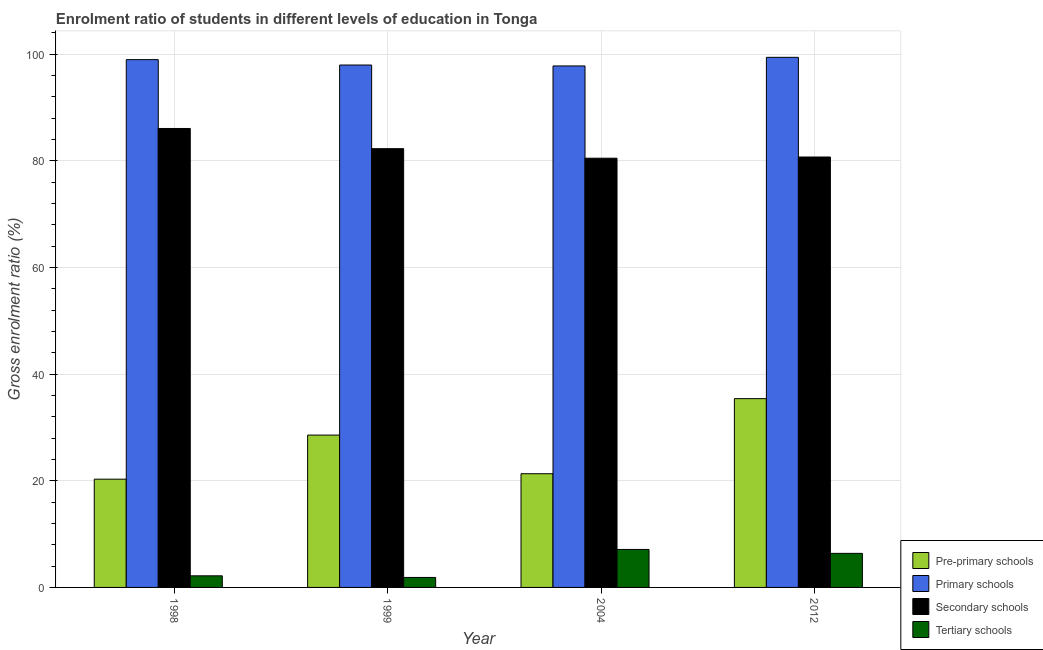How many groups of bars are there?
Keep it short and to the point. 4. Are the number of bars per tick equal to the number of legend labels?
Provide a succinct answer. Yes. How many bars are there on the 2nd tick from the right?
Make the answer very short. 4. What is the label of the 4th group of bars from the left?
Provide a short and direct response. 2012. What is the gross enrolment ratio in secondary schools in 2004?
Offer a very short reply. 80.49. Across all years, what is the maximum gross enrolment ratio in pre-primary schools?
Provide a short and direct response. 35.4. Across all years, what is the minimum gross enrolment ratio in tertiary schools?
Make the answer very short. 1.87. What is the total gross enrolment ratio in primary schools in the graph?
Offer a very short reply. 394.16. What is the difference between the gross enrolment ratio in primary schools in 1999 and that in 2012?
Offer a terse response. -1.44. What is the difference between the gross enrolment ratio in pre-primary schools in 1998 and the gross enrolment ratio in primary schools in 1999?
Offer a terse response. -8.27. What is the average gross enrolment ratio in primary schools per year?
Provide a succinct answer. 98.54. In the year 2012, what is the difference between the gross enrolment ratio in tertiary schools and gross enrolment ratio in secondary schools?
Provide a short and direct response. 0. In how many years, is the gross enrolment ratio in pre-primary schools greater than 48 %?
Provide a short and direct response. 0. What is the ratio of the gross enrolment ratio in pre-primary schools in 1999 to that in 2012?
Provide a short and direct response. 0.81. What is the difference between the highest and the second highest gross enrolment ratio in primary schools?
Offer a terse response. 0.43. What is the difference between the highest and the lowest gross enrolment ratio in primary schools?
Your answer should be very brief. 1.62. Is the sum of the gross enrolment ratio in primary schools in 1998 and 1999 greater than the maximum gross enrolment ratio in secondary schools across all years?
Offer a very short reply. Yes. Is it the case that in every year, the sum of the gross enrolment ratio in secondary schools and gross enrolment ratio in primary schools is greater than the sum of gross enrolment ratio in pre-primary schools and gross enrolment ratio in tertiary schools?
Your answer should be very brief. No. What does the 3rd bar from the left in 1998 represents?
Your answer should be compact. Secondary schools. What does the 2nd bar from the right in 2004 represents?
Offer a very short reply. Secondary schools. How many bars are there?
Offer a very short reply. 16. Does the graph contain any zero values?
Keep it short and to the point. No. Does the graph contain grids?
Provide a succinct answer. Yes. Where does the legend appear in the graph?
Provide a short and direct response. Bottom right. How are the legend labels stacked?
Offer a very short reply. Vertical. What is the title of the graph?
Provide a short and direct response. Enrolment ratio of students in different levels of education in Tonga. Does "International Development Association" appear as one of the legend labels in the graph?
Provide a succinct answer. No. What is the Gross enrolment ratio (%) of Pre-primary schools in 1998?
Provide a succinct answer. 20.3. What is the Gross enrolment ratio (%) in Primary schools in 1998?
Offer a very short reply. 98.98. What is the Gross enrolment ratio (%) of Secondary schools in 1998?
Give a very brief answer. 86.07. What is the Gross enrolment ratio (%) in Tertiary schools in 1998?
Ensure brevity in your answer.  2.18. What is the Gross enrolment ratio (%) of Pre-primary schools in 1999?
Provide a succinct answer. 28.57. What is the Gross enrolment ratio (%) in Primary schools in 1999?
Give a very brief answer. 97.97. What is the Gross enrolment ratio (%) of Secondary schools in 1999?
Your answer should be very brief. 82.28. What is the Gross enrolment ratio (%) of Tertiary schools in 1999?
Give a very brief answer. 1.87. What is the Gross enrolment ratio (%) in Pre-primary schools in 2004?
Your response must be concise. 21.32. What is the Gross enrolment ratio (%) in Primary schools in 2004?
Your answer should be compact. 97.8. What is the Gross enrolment ratio (%) in Secondary schools in 2004?
Ensure brevity in your answer.  80.49. What is the Gross enrolment ratio (%) in Tertiary schools in 2004?
Offer a very short reply. 7.12. What is the Gross enrolment ratio (%) of Pre-primary schools in 2012?
Offer a terse response. 35.4. What is the Gross enrolment ratio (%) in Primary schools in 2012?
Keep it short and to the point. 99.41. What is the Gross enrolment ratio (%) of Secondary schools in 2012?
Your response must be concise. 80.72. What is the Gross enrolment ratio (%) in Tertiary schools in 2012?
Ensure brevity in your answer.  6.39. Across all years, what is the maximum Gross enrolment ratio (%) in Pre-primary schools?
Offer a terse response. 35.4. Across all years, what is the maximum Gross enrolment ratio (%) of Primary schools?
Ensure brevity in your answer.  99.41. Across all years, what is the maximum Gross enrolment ratio (%) of Secondary schools?
Make the answer very short. 86.07. Across all years, what is the maximum Gross enrolment ratio (%) of Tertiary schools?
Ensure brevity in your answer.  7.12. Across all years, what is the minimum Gross enrolment ratio (%) in Pre-primary schools?
Keep it short and to the point. 20.3. Across all years, what is the minimum Gross enrolment ratio (%) of Primary schools?
Keep it short and to the point. 97.8. Across all years, what is the minimum Gross enrolment ratio (%) in Secondary schools?
Offer a terse response. 80.49. Across all years, what is the minimum Gross enrolment ratio (%) in Tertiary schools?
Your answer should be compact. 1.87. What is the total Gross enrolment ratio (%) in Pre-primary schools in the graph?
Offer a very short reply. 105.6. What is the total Gross enrolment ratio (%) of Primary schools in the graph?
Make the answer very short. 394.16. What is the total Gross enrolment ratio (%) in Secondary schools in the graph?
Your answer should be very brief. 329.57. What is the total Gross enrolment ratio (%) of Tertiary schools in the graph?
Provide a succinct answer. 17.56. What is the difference between the Gross enrolment ratio (%) in Pre-primary schools in 1998 and that in 1999?
Your answer should be compact. -8.27. What is the difference between the Gross enrolment ratio (%) of Primary schools in 1998 and that in 1999?
Give a very brief answer. 1.01. What is the difference between the Gross enrolment ratio (%) in Secondary schools in 1998 and that in 1999?
Keep it short and to the point. 3.79. What is the difference between the Gross enrolment ratio (%) of Tertiary schools in 1998 and that in 1999?
Give a very brief answer. 0.31. What is the difference between the Gross enrolment ratio (%) in Pre-primary schools in 1998 and that in 2004?
Offer a very short reply. -1.02. What is the difference between the Gross enrolment ratio (%) in Primary schools in 1998 and that in 2004?
Provide a succinct answer. 1.18. What is the difference between the Gross enrolment ratio (%) of Secondary schools in 1998 and that in 2004?
Your response must be concise. 5.58. What is the difference between the Gross enrolment ratio (%) of Tertiary schools in 1998 and that in 2004?
Your answer should be compact. -4.95. What is the difference between the Gross enrolment ratio (%) of Pre-primary schools in 1998 and that in 2012?
Give a very brief answer. -15.1. What is the difference between the Gross enrolment ratio (%) of Primary schools in 1998 and that in 2012?
Make the answer very short. -0.43. What is the difference between the Gross enrolment ratio (%) of Secondary schools in 1998 and that in 2012?
Keep it short and to the point. 5.35. What is the difference between the Gross enrolment ratio (%) in Tertiary schools in 1998 and that in 2012?
Provide a succinct answer. -4.21. What is the difference between the Gross enrolment ratio (%) of Pre-primary schools in 1999 and that in 2004?
Make the answer very short. 7.25. What is the difference between the Gross enrolment ratio (%) of Primary schools in 1999 and that in 2004?
Give a very brief answer. 0.17. What is the difference between the Gross enrolment ratio (%) of Secondary schools in 1999 and that in 2004?
Your answer should be compact. 1.79. What is the difference between the Gross enrolment ratio (%) of Tertiary schools in 1999 and that in 2004?
Your answer should be very brief. -5.25. What is the difference between the Gross enrolment ratio (%) of Pre-primary schools in 1999 and that in 2012?
Provide a succinct answer. -6.83. What is the difference between the Gross enrolment ratio (%) in Primary schools in 1999 and that in 2012?
Your answer should be very brief. -1.44. What is the difference between the Gross enrolment ratio (%) of Secondary schools in 1999 and that in 2012?
Provide a short and direct response. 1.56. What is the difference between the Gross enrolment ratio (%) in Tertiary schools in 1999 and that in 2012?
Keep it short and to the point. -4.52. What is the difference between the Gross enrolment ratio (%) in Pre-primary schools in 2004 and that in 2012?
Your response must be concise. -14.08. What is the difference between the Gross enrolment ratio (%) of Primary schools in 2004 and that in 2012?
Your answer should be very brief. -1.62. What is the difference between the Gross enrolment ratio (%) of Secondary schools in 2004 and that in 2012?
Make the answer very short. -0.22. What is the difference between the Gross enrolment ratio (%) in Tertiary schools in 2004 and that in 2012?
Offer a very short reply. 0.74. What is the difference between the Gross enrolment ratio (%) in Pre-primary schools in 1998 and the Gross enrolment ratio (%) in Primary schools in 1999?
Your response must be concise. -77.67. What is the difference between the Gross enrolment ratio (%) of Pre-primary schools in 1998 and the Gross enrolment ratio (%) of Secondary schools in 1999?
Make the answer very short. -61.98. What is the difference between the Gross enrolment ratio (%) in Pre-primary schools in 1998 and the Gross enrolment ratio (%) in Tertiary schools in 1999?
Your response must be concise. 18.43. What is the difference between the Gross enrolment ratio (%) of Primary schools in 1998 and the Gross enrolment ratio (%) of Secondary schools in 1999?
Ensure brevity in your answer.  16.7. What is the difference between the Gross enrolment ratio (%) of Primary schools in 1998 and the Gross enrolment ratio (%) of Tertiary schools in 1999?
Your answer should be very brief. 97.11. What is the difference between the Gross enrolment ratio (%) of Secondary schools in 1998 and the Gross enrolment ratio (%) of Tertiary schools in 1999?
Provide a short and direct response. 84.2. What is the difference between the Gross enrolment ratio (%) in Pre-primary schools in 1998 and the Gross enrolment ratio (%) in Primary schools in 2004?
Provide a short and direct response. -77.5. What is the difference between the Gross enrolment ratio (%) of Pre-primary schools in 1998 and the Gross enrolment ratio (%) of Secondary schools in 2004?
Keep it short and to the point. -60.19. What is the difference between the Gross enrolment ratio (%) of Pre-primary schools in 1998 and the Gross enrolment ratio (%) of Tertiary schools in 2004?
Make the answer very short. 13.18. What is the difference between the Gross enrolment ratio (%) in Primary schools in 1998 and the Gross enrolment ratio (%) in Secondary schools in 2004?
Give a very brief answer. 18.49. What is the difference between the Gross enrolment ratio (%) in Primary schools in 1998 and the Gross enrolment ratio (%) in Tertiary schools in 2004?
Your response must be concise. 91.86. What is the difference between the Gross enrolment ratio (%) of Secondary schools in 1998 and the Gross enrolment ratio (%) of Tertiary schools in 2004?
Provide a succinct answer. 78.95. What is the difference between the Gross enrolment ratio (%) of Pre-primary schools in 1998 and the Gross enrolment ratio (%) of Primary schools in 2012?
Ensure brevity in your answer.  -79.11. What is the difference between the Gross enrolment ratio (%) in Pre-primary schools in 1998 and the Gross enrolment ratio (%) in Secondary schools in 2012?
Your answer should be compact. -60.42. What is the difference between the Gross enrolment ratio (%) of Pre-primary schools in 1998 and the Gross enrolment ratio (%) of Tertiary schools in 2012?
Your answer should be very brief. 13.91. What is the difference between the Gross enrolment ratio (%) of Primary schools in 1998 and the Gross enrolment ratio (%) of Secondary schools in 2012?
Your answer should be very brief. 18.26. What is the difference between the Gross enrolment ratio (%) of Primary schools in 1998 and the Gross enrolment ratio (%) of Tertiary schools in 2012?
Your answer should be compact. 92.59. What is the difference between the Gross enrolment ratio (%) in Secondary schools in 1998 and the Gross enrolment ratio (%) in Tertiary schools in 2012?
Offer a very short reply. 79.68. What is the difference between the Gross enrolment ratio (%) in Pre-primary schools in 1999 and the Gross enrolment ratio (%) in Primary schools in 2004?
Offer a terse response. -69.23. What is the difference between the Gross enrolment ratio (%) of Pre-primary schools in 1999 and the Gross enrolment ratio (%) of Secondary schools in 2004?
Provide a short and direct response. -51.93. What is the difference between the Gross enrolment ratio (%) in Pre-primary schools in 1999 and the Gross enrolment ratio (%) in Tertiary schools in 2004?
Give a very brief answer. 21.45. What is the difference between the Gross enrolment ratio (%) of Primary schools in 1999 and the Gross enrolment ratio (%) of Secondary schools in 2004?
Provide a short and direct response. 17.48. What is the difference between the Gross enrolment ratio (%) of Primary schools in 1999 and the Gross enrolment ratio (%) of Tertiary schools in 2004?
Give a very brief answer. 90.85. What is the difference between the Gross enrolment ratio (%) in Secondary schools in 1999 and the Gross enrolment ratio (%) in Tertiary schools in 2004?
Provide a short and direct response. 75.16. What is the difference between the Gross enrolment ratio (%) of Pre-primary schools in 1999 and the Gross enrolment ratio (%) of Primary schools in 2012?
Ensure brevity in your answer.  -70.84. What is the difference between the Gross enrolment ratio (%) in Pre-primary schools in 1999 and the Gross enrolment ratio (%) in Secondary schools in 2012?
Offer a terse response. -52.15. What is the difference between the Gross enrolment ratio (%) of Pre-primary schools in 1999 and the Gross enrolment ratio (%) of Tertiary schools in 2012?
Provide a short and direct response. 22.18. What is the difference between the Gross enrolment ratio (%) of Primary schools in 1999 and the Gross enrolment ratio (%) of Secondary schools in 2012?
Offer a terse response. 17.25. What is the difference between the Gross enrolment ratio (%) in Primary schools in 1999 and the Gross enrolment ratio (%) in Tertiary schools in 2012?
Keep it short and to the point. 91.58. What is the difference between the Gross enrolment ratio (%) in Secondary schools in 1999 and the Gross enrolment ratio (%) in Tertiary schools in 2012?
Your response must be concise. 75.9. What is the difference between the Gross enrolment ratio (%) of Pre-primary schools in 2004 and the Gross enrolment ratio (%) of Primary schools in 2012?
Provide a short and direct response. -78.09. What is the difference between the Gross enrolment ratio (%) of Pre-primary schools in 2004 and the Gross enrolment ratio (%) of Secondary schools in 2012?
Provide a succinct answer. -59.4. What is the difference between the Gross enrolment ratio (%) of Pre-primary schools in 2004 and the Gross enrolment ratio (%) of Tertiary schools in 2012?
Ensure brevity in your answer.  14.94. What is the difference between the Gross enrolment ratio (%) of Primary schools in 2004 and the Gross enrolment ratio (%) of Secondary schools in 2012?
Make the answer very short. 17.08. What is the difference between the Gross enrolment ratio (%) in Primary schools in 2004 and the Gross enrolment ratio (%) in Tertiary schools in 2012?
Provide a short and direct response. 91.41. What is the difference between the Gross enrolment ratio (%) of Secondary schools in 2004 and the Gross enrolment ratio (%) of Tertiary schools in 2012?
Ensure brevity in your answer.  74.11. What is the average Gross enrolment ratio (%) of Pre-primary schools per year?
Provide a succinct answer. 26.4. What is the average Gross enrolment ratio (%) in Primary schools per year?
Your response must be concise. 98.54. What is the average Gross enrolment ratio (%) in Secondary schools per year?
Offer a terse response. 82.39. What is the average Gross enrolment ratio (%) of Tertiary schools per year?
Offer a terse response. 4.39. In the year 1998, what is the difference between the Gross enrolment ratio (%) of Pre-primary schools and Gross enrolment ratio (%) of Primary schools?
Make the answer very short. -78.68. In the year 1998, what is the difference between the Gross enrolment ratio (%) of Pre-primary schools and Gross enrolment ratio (%) of Secondary schools?
Ensure brevity in your answer.  -65.77. In the year 1998, what is the difference between the Gross enrolment ratio (%) in Pre-primary schools and Gross enrolment ratio (%) in Tertiary schools?
Provide a short and direct response. 18.12. In the year 1998, what is the difference between the Gross enrolment ratio (%) in Primary schools and Gross enrolment ratio (%) in Secondary schools?
Ensure brevity in your answer.  12.91. In the year 1998, what is the difference between the Gross enrolment ratio (%) in Primary schools and Gross enrolment ratio (%) in Tertiary schools?
Make the answer very short. 96.8. In the year 1998, what is the difference between the Gross enrolment ratio (%) in Secondary schools and Gross enrolment ratio (%) in Tertiary schools?
Make the answer very short. 83.89. In the year 1999, what is the difference between the Gross enrolment ratio (%) in Pre-primary schools and Gross enrolment ratio (%) in Primary schools?
Your answer should be very brief. -69.4. In the year 1999, what is the difference between the Gross enrolment ratio (%) of Pre-primary schools and Gross enrolment ratio (%) of Secondary schools?
Offer a very short reply. -53.71. In the year 1999, what is the difference between the Gross enrolment ratio (%) in Pre-primary schools and Gross enrolment ratio (%) in Tertiary schools?
Give a very brief answer. 26.7. In the year 1999, what is the difference between the Gross enrolment ratio (%) of Primary schools and Gross enrolment ratio (%) of Secondary schools?
Ensure brevity in your answer.  15.69. In the year 1999, what is the difference between the Gross enrolment ratio (%) of Primary schools and Gross enrolment ratio (%) of Tertiary schools?
Your answer should be very brief. 96.1. In the year 1999, what is the difference between the Gross enrolment ratio (%) in Secondary schools and Gross enrolment ratio (%) in Tertiary schools?
Your answer should be compact. 80.41. In the year 2004, what is the difference between the Gross enrolment ratio (%) of Pre-primary schools and Gross enrolment ratio (%) of Primary schools?
Give a very brief answer. -76.47. In the year 2004, what is the difference between the Gross enrolment ratio (%) of Pre-primary schools and Gross enrolment ratio (%) of Secondary schools?
Keep it short and to the point. -59.17. In the year 2004, what is the difference between the Gross enrolment ratio (%) in Pre-primary schools and Gross enrolment ratio (%) in Tertiary schools?
Your answer should be compact. 14.2. In the year 2004, what is the difference between the Gross enrolment ratio (%) in Primary schools and Gross enrolment ratio (%) in Secondary schools?
Your answer should be very brief. 17.3. In the year 2004, what is the difference between the Gross enrolment ratio (%) in Primary schools and Gross enrolment ratio (%) in Tertiary schools?
Your answer should be compact. 90.67. In the year 2004, what is the difference between the Gross enrolment ratio (%) in Secondary schools and Gross enrolment ratio (%) in Tertiary schools?
Give a very brief answer. 73.37. In the year 2012, what is the difference between the Gross enrolment ratio (%) of Pre-primary schools and Gross enrolment ratio (%) of Primary schools?
Your answer should be compact. -64.01. In the year 2012, what is the difference between the Gross enrolment ratio (%) in Pre-primary schools and Gross enrolment ratio (%) in Secondary schools?
Offer a very short reply. -45.32. In the year 2012, what is the difference between the Gross enrolment ratio (%) in Pre-primary schools and Gross enrolment ratio (%) in Tertiary schools?
Keep it short and to the point. 29.02. In the year 2012, what is the difference between the Gross enrolment ratio (%) in Primary schools and Gross enrolment ratio (%) in Secondary schools?
Your response must be concise. 18.69. In the year 2012, what is the difference between the Gross enrolment ratio (%) of Primary schools and Gross enrolment ratio (%) of Tertiary schools?
Offer a terse response. 93.03. In the year 2012, what is the difference between the Gross enrolment ratio (%) of Secondary schools and Gross enrolment ratio (%) of Tertiary schools?
Your answer should be very brief. 74.33. What is the ratio of the Gross enrolment ratio (%) in Pre-primary schools in 1998 to that in 1999?
Ensure brevity in your answer.  0.71. What is the ratio of the Gross enrolment ratio (%) of Primary schools in 1998 to that in 1999?
Ensure brevity in your answer.  1.01. What is the ratio of the Gross enrolment ratio (%) of Secondary schools in 1998 to that in 1999?
Provide a short and direct response. 1.05. What is the ratio of the Gross enrolment ratio (%) of Tertiary schools in 1998 to that in 1999?
Keep it short and to the point. 1.16. What is the ratio of the Gross enrolment ratio (%) in Pre-primary schools in 1998 to that in 2004?
Make the answer very short. 0.95. What is the ratio of the Gross enrolment ratio (%) in Primary schools in 1998 to that in 2004?
Provide a short and direct response. 1.01. What is the ratio of the Gross enrolment ratio (%) of Secondary schools in 1998 to that in 2004?
Your response must be concise. 1.07. What is the ratio of the Gross enrolment ratio (%) in Tertiary schools in 1998 to that in 2004?
Your response must be concise. 0.31. What is the ratio of the Gross enrolment ratio (%) of Pre-primary schools in 1998 to that in 2012?
Offer a very short reply. 0.57. What is the ratio of the Gross enrolment ratio (%) in Secondary schools in 1998 to that in 2012?
Your answer should be compact. 1.07. What is the ratio of the Gross enrolment ratio (%) of Tertiary schools in 1998 to that in 2012?
Offer a terse response. 0.34. What is the ratio of the Gross enrolment ratio (%) of Pre-primary schools in 1999 to that in 2004?
Make the answer very short. 1.34. What is the ratio of the Gross enrolment ratio (%) in Primary schools in 1999 to that in 2004?
Keep it short and to the point. 1. What is the ratio of the Gross enrolment ratio (%) of Secondary schools in 1999 to that in 2004?
Ensure brevity in your answer.  1.02. What is the ratio of the Gross enrolment ratio (%) in Tertiary schools in 1999 to that in 2004?
Your answer should be very brief. 0.26. What is the ratio of the Gross enrolment ratio (%) in Pre-primary schools in 1999 to that in 2012?
Your answer should be compact. 0.81. What is the ratio of the Gross enrolment ratio (%) of Primary schools in 1999 to that in 2012?
Provide a short and direct response. 0.99. What is the ratio of the Gross enrolment ratio (%) in Secondary schools in 1999 to that in 2012?
Ensure brevity in your answer.  1.02. What is the ratio of the Gross enrolment ratio (%) of Tertiary schools in 1999 to that in 2012?
Keep it short and to the point. 0.29. What is the ratio of the Gross enrolment ratio (%) in Pre-primary schools in 2004 to that in 2012?
Your answer should be compact. 0.6. What is the ratio of the Gross enrolment ratio (%) of Primary schools in 2004 to that in 2012?
Keep it short and to the point. 0.98. What is the ratio of the Gross enrolment ratio (%) in Secondary schools in 2004 to that in 2012?
Give a very brief answer. 1. What is the ratio of the Gross enrolment ratio (%) in Tertiary schools in 2004 to that in 2012?
Your answer should be very brief. 1.12. What is the difference between the highest and the second highest Gross enrolment ratio (%) of Pre-primary schools?
Your response must be concise. 6.83. What is the difference between the highest and the second highest Gross enrolment ratio (%) in Primary schools?
Offer a terse response. 0.43. What is the difference between the highest and the second highest Gross enrolment ratio (%) in Secondary schools?
Ensure brevity in your answer.  3.79. What is the difference between the highest and the second highest Gross enrolment ratio (%) in Tertiary schools?
Make the answer very short. 0.74. What is the difference between the highest and the lowest Gross enrolment ratio (%) of Pre-primary schools?
Offer a very short reply. 15.1. What is the difference between the highest and the lowest Gross enrolment ratio (%) of Primary schools?
Provide a succinct answer. 1.62. What is the difference between the highest and the lowest Gross enrolment ratio (%) in Secondary schools?
Ensure brevity in your answer.  5.58. What is the difference between the highest and the lowest Gross enrolment ratio (%) of Tertiary schools?
Your answer should be very brief. 5.25. 